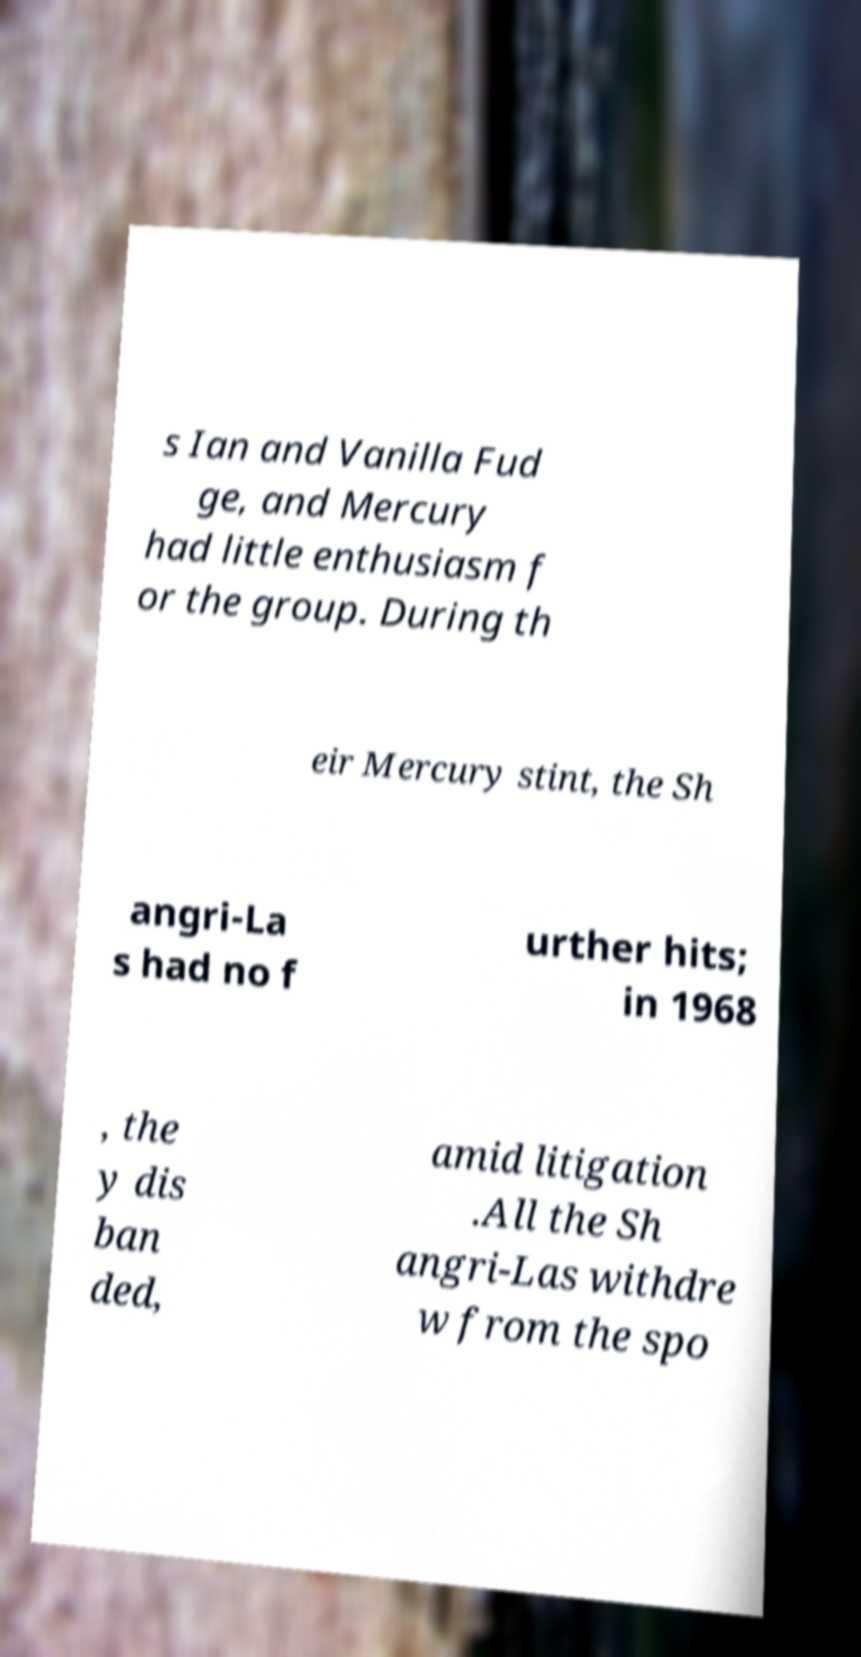Can you read and provide the text displayed in the image?This photo seems to have some interesting text. Can you extract and type it out for me? s Ian and Vanilla Fud ge, and Mercury had little enthusiasm f or the group. During th eir Mercury stint, the Sh angri-La s had no f urther hits; in 1968 , the y dis ban ded, amid litigation .All the Sh angri-Las withdre w from the spo 